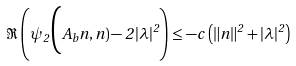Convert formula to latex. <formula><loc_0><loc_0><loc_500><loc_500>\Re \left ( \psi _ { 2 } \Big ( A _ { b } n , n ) - 2 \, | \lambda | ^ { 2 } \right ) \leq - c \, \left ( \| n \| ^ { 2 } + | \lambda | ^ { 2 } \right )</formula> 